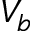Convert formula to latex. <formula><loc_0><loc_0><loc_500><loc_500>V _ { b }</formula> 